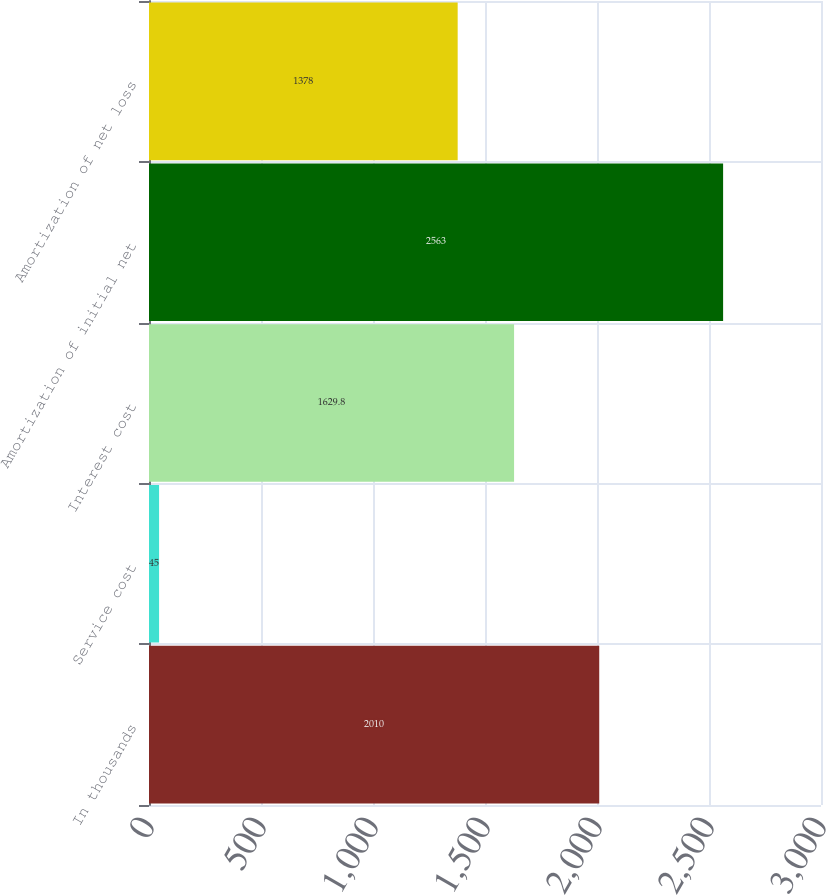Convert chart. <chart><loc_0><loc_0><loc_500><loc_500><bar_chart><fcel>In thousands<fcel>Service cost<fcel>Interest cost<fcel>Amortization of initial net<fcel>Amortization of net loss<nl><fcel>2010<fcel>45<fcel>1629.8<fcel>2563<fcel>1378<nl></chart> 